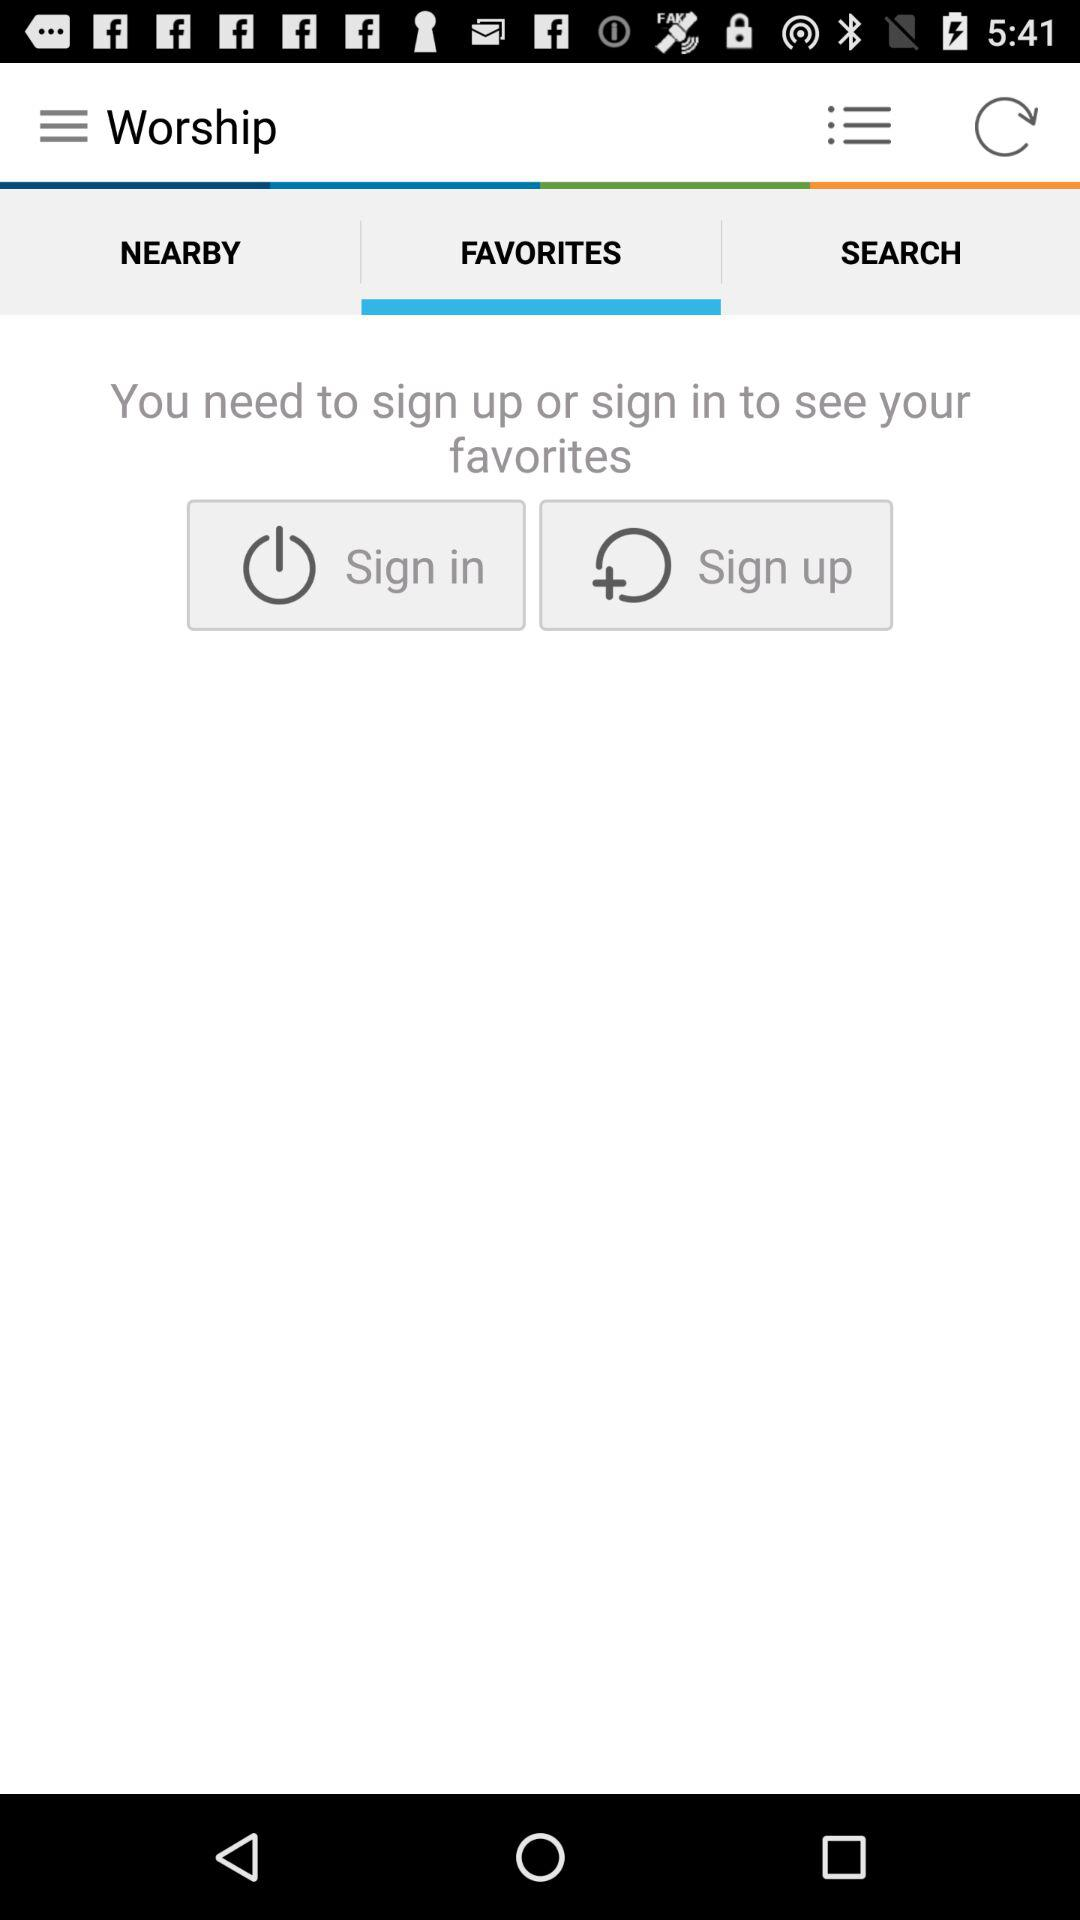Which tab is selected? The selected tab is "Favorites". 